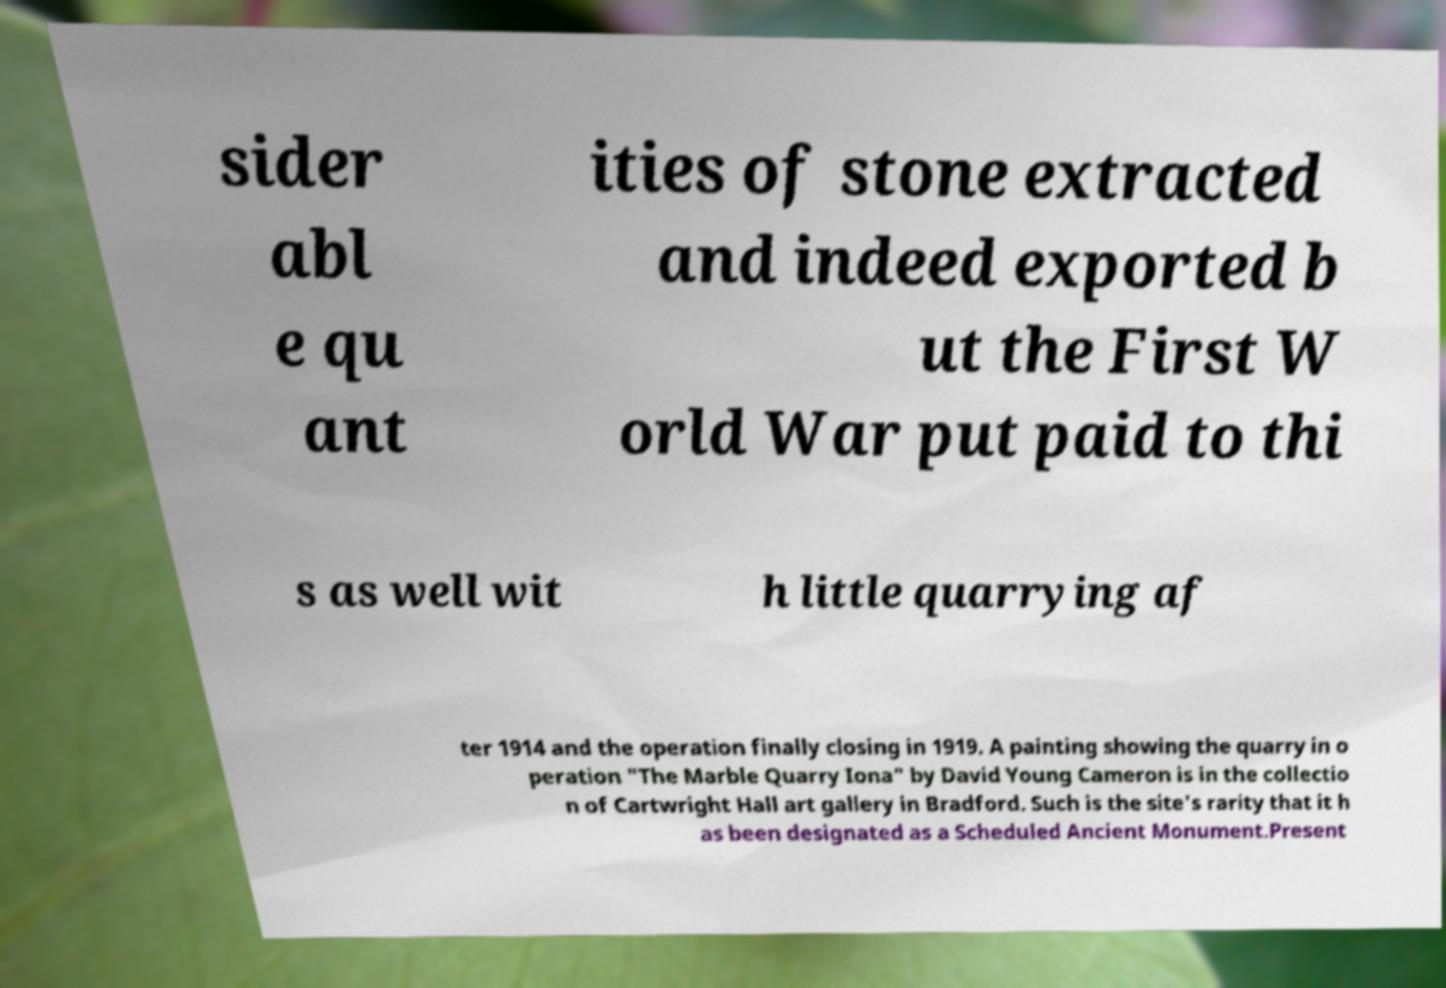Please read and relay the text visible in this image. What does it say? sider abl e qu ant ities of stone extracted and indeed exported b ut the First W orld War put paid to thi s as well wit h little quarrying af ter 1914 and the operation finally closing in 1919. A painting showing the quarry in o peration "The Marble Quarry Iona" by David Young Cameron is in the collectio n of Cartwright Hall art gallery in Bradford. Such is the site's rarity that it h as been designated as a Scheduled Ancient Monument.Present 